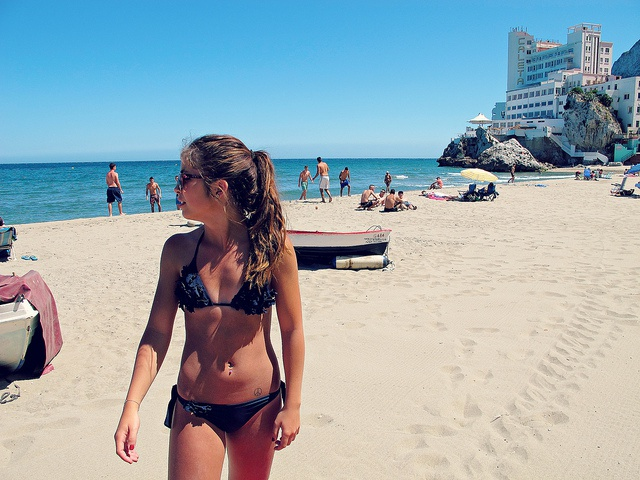Describe the objects in this image and their specific colors. I can see people in gray, black, maroon, brown, and salmon tones, boat in gray, black, darkgray, lightpink, and brown tones, boat in gray, black, darkgray, and lightgray tones, people in gray, black, brown, navy, and salmon tones, and people in gray, darkgray, tan, black, and maroon tones in this image. 